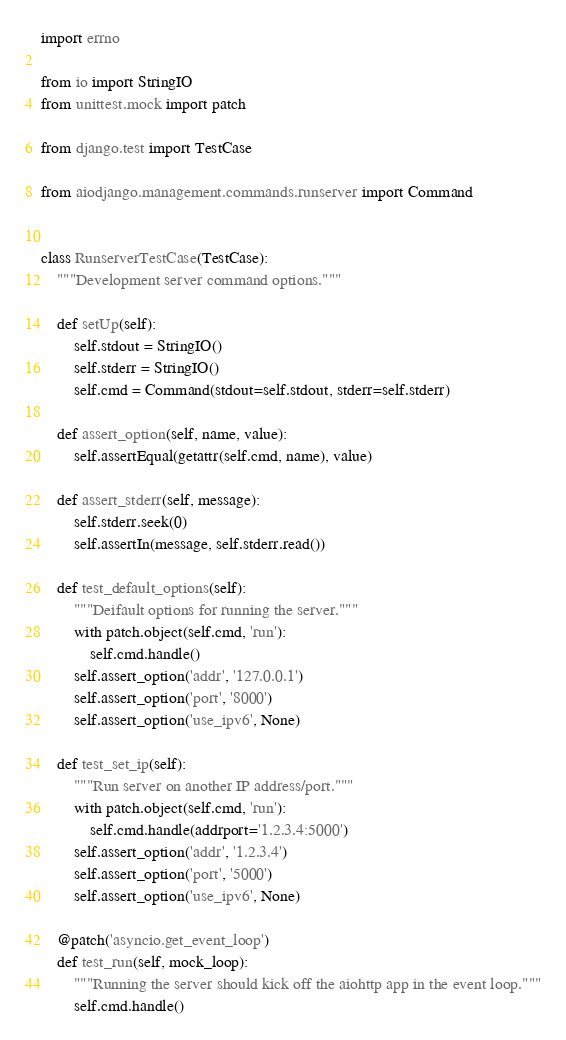Convert code to text. <code><loc_0><loc_0><loc_500><loc_500><_Python_>import errno

from io import StringIO
from unittest.mock import patch

from django.test import TestCase

from aiodjango.management.commands.runserver import Command


class RunserverTestCase(TestCase):
    """Development server command options."""

    def setUp(self):
        self.stdout = StringIO()
        self.stderr = StringIO()
        self.cmd = Command(stdout=self.stdout, stderr=self.stderr)

    def assert_option(self, name, value):
        self.assertEqual(getattr(self.cmd, name), value)

    def assert_stderr(self, message):
        self.stderr.seek(0)
        self.assertIn(message, self.stderr.read())

    def test_default_options(self):
        """Deifault options for running the server."""
        with patch.object(self.cmd, 'run'):
            self.cmd.handle()
        self.assert_option('addr', '127.0.0.1')
        self.assert_option('port', '8000')
        self.assert_option('use_ipv6', None)

    def test_set_ip(self):
        """Run server on another IP address/port."""
        with patch.object(self.cmd, 'run'):
            self.cmd.handle(addrport='1.2.3.4:5000')
        self.assert_option('addr', '1.2.3.4')
        self.assert_option('port', '5000')
        self.assert_option('use_ipv6', None)

    @patch('asyncio.get_event_loop')
    def test_run(self, mock_loop):
        """Running the server should kick off the aiohttp app in the event loop."""
        self.cmd.handle()</code> 